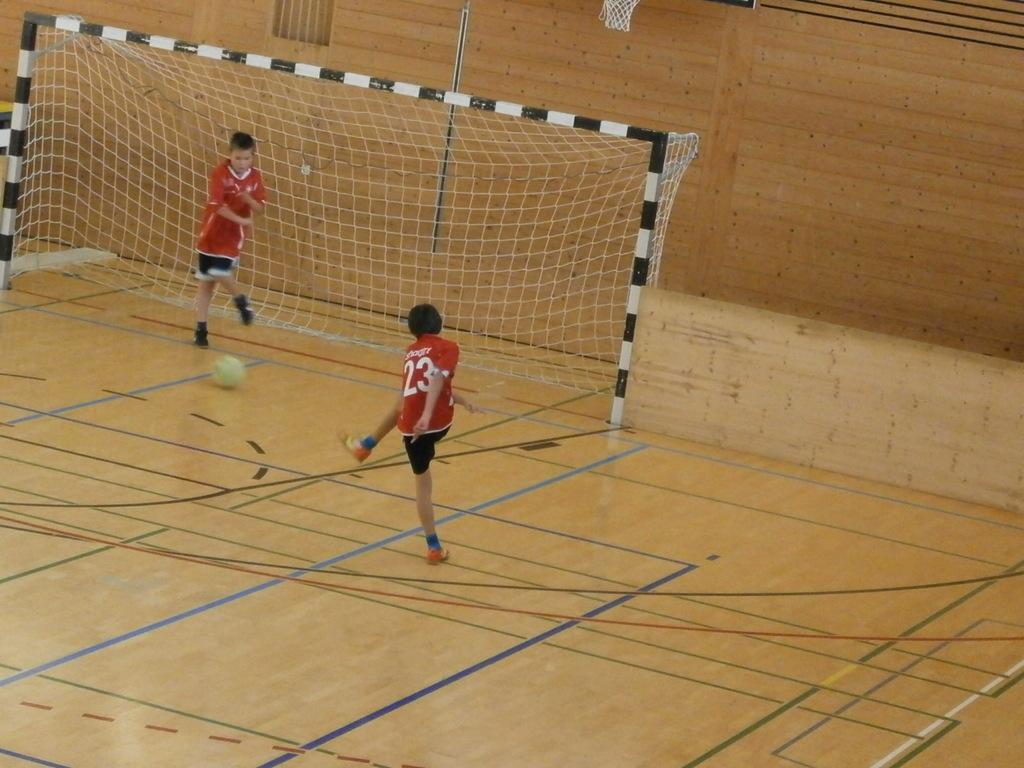What is the front player's jersey number?
Ensure brevity in your answer.  23. 